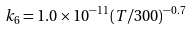Convert formula to latex. <formula><loc_0><loc_0><loc_500><loc_500>k _ { 6 } = 1 . 0 \times 1 0 ^ { - 1 1 } ( T / 3 0 0 ) ^ { - 0 . 7 }</formula> 